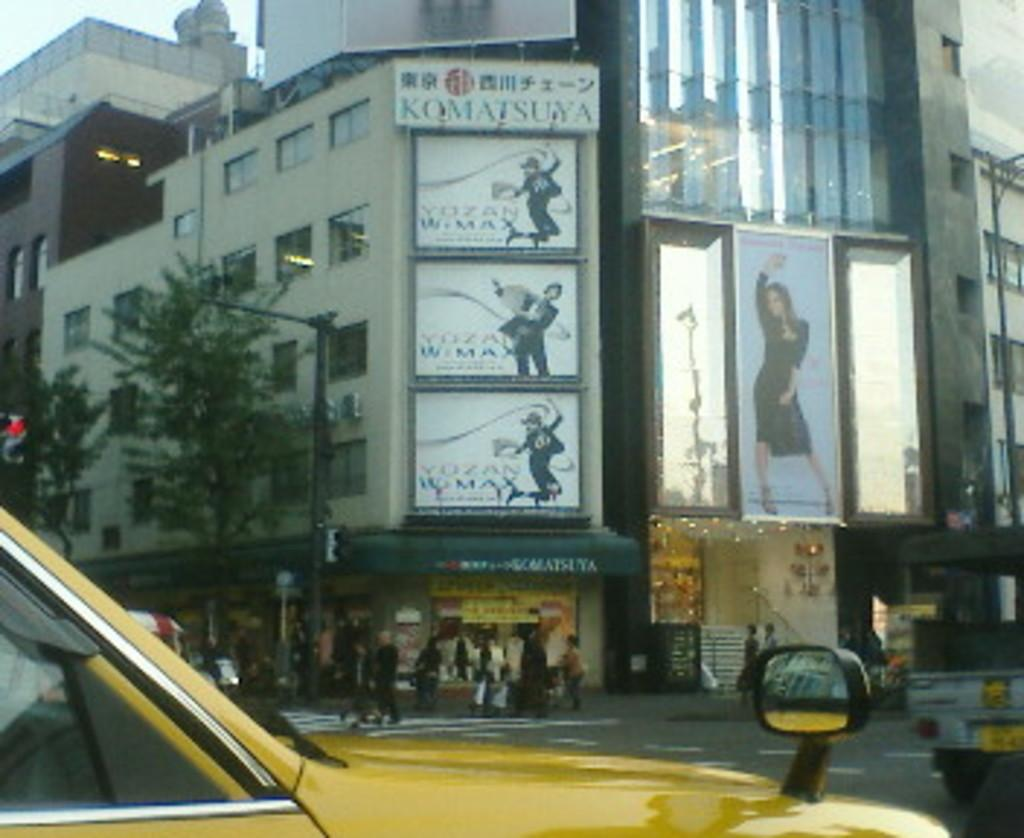<image>
Relay a brief, clear account of the picture shown. The advertisement on the building is for KQMATSUYA. 